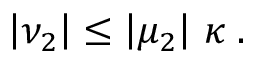<formula> <loc_0><loc_0><loc_500><loc_500>\left | \nu _ { 2 } \right | \leq \left | \mu _ { 2 } \right | \, \kappa \, .</formula> 